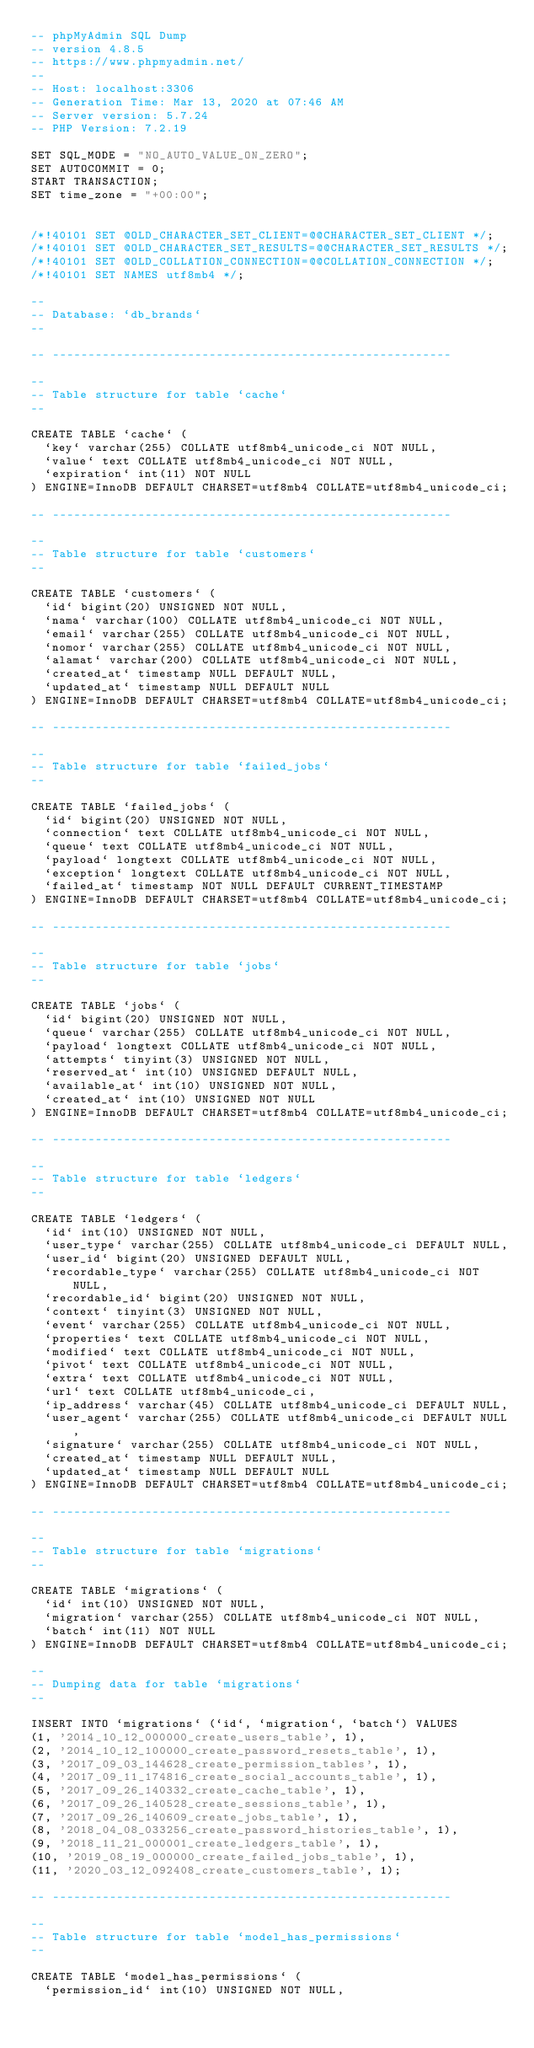Convert code to text. <code><loc_0><loc_0><loc_500><loc_500><_SQL_>-- phpMyAdmin SQL Dump
-- version 4.8.5
-- https://www.phpmyadmin.net/
--
-- Host: localhost:3306
-- Generation Time: Mar 13, 2020 at 07:46 AM
-- Server version: 5.7.24
-- PHP Version: 7.2.19

SET SQL_MODE = "NO_AUTO_VALUE_ON_ZERO";
SET AUTOCOMMIT = 0;
START TRANSACTION;
SET time_zone = "+00:00";


/*!40101 SET @OLD_CHARACTER_SET_CLIENT=@@CHARACTER_SET_CLIENT */;
/*!40101 SET @OLD_CHARACTER_SET_RESULTS=@@CHARACTER_SET_RESULTS */;
/*!40101 SET @OLD_COLLATION_CONNECTION=@@COLLATION_CONNECTION */;
/*!40101 SET NAMES utf8mb4 */;

--
-- Database: `db_brands`
--

-- --------------------------------------------------------

--
-- Table structure for table `cache`
--

CREATE TABLE `cache` (
  `key` varchar(255) COLLATE utf8mb4_unicode_ci NOT NULL,
  `value` text COLLATE utf8mb4_unicode_ci NOT NULL,
  `expiration` int(11) NOT NULL
) ENGINE=InnoDB DEFAULT CHARSET=utf8mb4 COLLATE=utf8mb4_unicode_ci;

-- --------------------------------------------------------

--
-- Table structure for table `customers`
--

CREATE TABLE `customers` (
  `id` bigint(20) UNSIGNED NOT NULL,
  `nama` varchar(100) COLLATE utf8mb4_unicode_ci NOT NULL,
  `email` varchar(255) COLLATE utf8mb4_unicode_ci NOT NULL,
  `nomor` varchar(255) COLLATE utf8mb4_unicode_ci NOT NULL,
  `alamat` varchar(200) COLLATE utf8mb4_unicode_ci NOT NULL,
  `created_at` timestamp NULL DEFAULT NULL,
  `updated_at` timestamp NULL DEFAULT NULL
) ENGINE=InnoDB DEFAULT CHARSET=utf8mb4 COLLATE=utf8mb4_unicode_ci;

-- --------------------------------------------------------

--
-- Table structure for table `failed_jobs`
--

CREATE TABLE `failed_jobs` (
  `id` bigint(20) UNSIGNED NOT NULL,
  `connection` text COLLATE utf8mb4_unicode_ci NOT NULL,
  `queue` text COLLATE utf8mb4_unicode_ci NOT NULL,
  `payload` longtext COLLATE utf8mb4_unicode_ci NOT NULL,
  `exception` longtext COLLATE utf8mb4_unicode_ci NOT NULL,
  `failed_at` timestamp NOT NULL DEFAULT CURRENT_TIMESTAMP
) ENGINE=InnoDB DEFAULT CHARSET=utf8mb4 COLLATE=utf8mb4_unicode_ci;

-- --------------------------------------------------------

--
-- Table structure for table `jobs`
--

CREATE TABLE `jobs` (
  `id` bigint(20) UNSIGNED NOT NULL,
  `queue` varchar(255) COLLATE utf8mb4_unicode_ci NOT NULL,
  `payload` longtext COLLATE utf8mb4_unicode_ci NOT NULL,
  `attempts` tinyint(3) UNSIGNED NOT NULL,
  `reserved_at` int(10) UNSIGNED DEFAULT NULL,
  `available_at` int(10) UNSIGNED NOT NULL,
  `created_at` int(10) UNSIGNED NOT NULL
) ENGINE=InnoDB DEFAULT CHARSET=utf8mb4 COLLATE=utf8mb4_unicode_ci;

-- --------------------------------------------------------

--
-- Table structure for table `ledgers`
--

CREATE TABLE `ledgers` (
  `id` int(10) UNSIGNED NOT NULL,
  `user_type` varchar(255) COLLATE utf8mb4_unicode_ci DEFAULT NULL,
  `user_id` bigint(20) UNSIGNED DEFAULT NULL,
  `recordable_type` varchar(255) COLLATE utf8mb4_unicode_ci NOT NULL,
  `recordable_id` bigint(20) UNSIGNED NOT NULL,
  `context` tinyint(3) UNSIGNED NOT NULL,
  `event` varchar(255) COLLATE utf8mb4_unicode_ci NOT NULL,
  `properties` text COLLATE utf8mb4_unicode_ci NOT NULL,
  `modified` text COLLATE utf8mb4_unicode_ci NOT NULL,
  `pivot` text COLLATE utf8mb4_unicode_ci NOT NULL,
  `extra` text COLLATE utf8mb4_unicode_ci NOT NULL,
  `url` text COLLATE utf8mb4_unicode_ci,
  `ip_address` varchar(45) COLLATE utf8mb4_unicode_ci DEFAULT NULL,
  `user_agent` varchar(255) COLLATE utf8mb4_unicode_ci DEFAULT NULL,
  `signature` varchar(255) COLLATE utf8mb4_unicode_ci NOT NULL,
  `created_at` timestamp NULL DEFAULT NULL,
  `updated_at` timestamp NULL DEFAULT NULL
) ENGINE=InnoDB DEFAULT CHARSET=utf8mb4 COLLATE=utf8mb4_unicode_ci;

-- --------------------------------------------------------

--
-- Table structure for table `migrations`
--

CREATE TABLE `migrations` (
  `id` int(10) UNSIGNED NOT NULL,
  `migration` varchar(255) COLLATE utf8mb4_unicode_ci NOT NULL,
  `batch` int(11) NOT NULL
) ENGINE=InnoDB DEFAULT CHARSET=utf8mb4 COLLATE=utf8mb4_unicode_ci;

--
-- Dumping data for table `migrations`
--

INSERT INTO `migrations` (`id`, `migration`, `batch`) VALUES
(1, '2014_10_12_000000_create_users_table', 1),
(2, '2014_10_12_100000_create_password_resets_table', 1),
(3, '2017_09_03_144628_create_permission_tables', 1),
(4, '2017_09_11_174816_create_social_accounts_table', 1),
(5, '2017_09_26_140332_create_cache_table', 1),
(6, '2017_09_26_140528_create_sessions_table', 1),
(7, '2017_09_26_140609_create_jobs_table', 1),
(8, '2018_04_08_033256_create_password_histories_table', 1),
(9, '2018_11_21_000001_create_ledgers_table', 1),
(10, '2019_08_19_000000_create_failed_jobs_table', 1),
(11, '2020_03_12_092408_create_customers_table', 1);

-- --------------------------------------------------------

--
-- Table structure for table `model_has_permissions`
--

CREATE TABLE `model_has_permissions` (
  `permission_id` int(10) UNSIGNED NOT NULL,</code> 